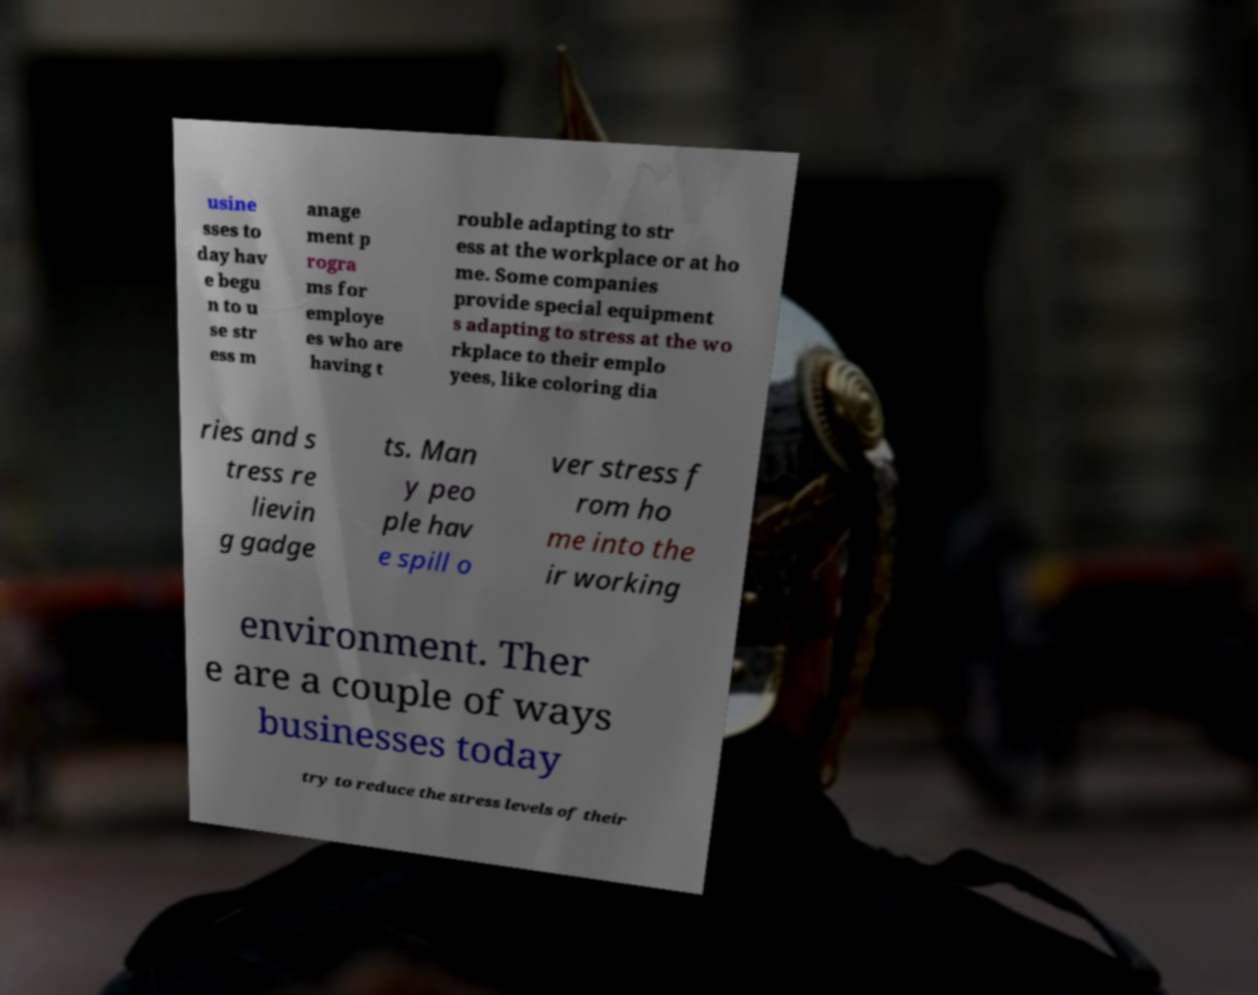What messages or text are displayed in this image? I need them in a readable, typed format. usine sses to day hav e begu n to u se str ess m anage ment p rogra ms for employe es who are having t rouble adapting to str ess at the workplace or at ho me. Some companies provide special equipment s adapting to stress at the wo rkplace to their emplo yees, like coloring dia ries and s tress re lievin g gadge ts. Man y peo ple hav e spill o ver stress f rom ho me into the ir working environment. Ther e are a couple of ways businesses today try to reduce the stress levels of their 